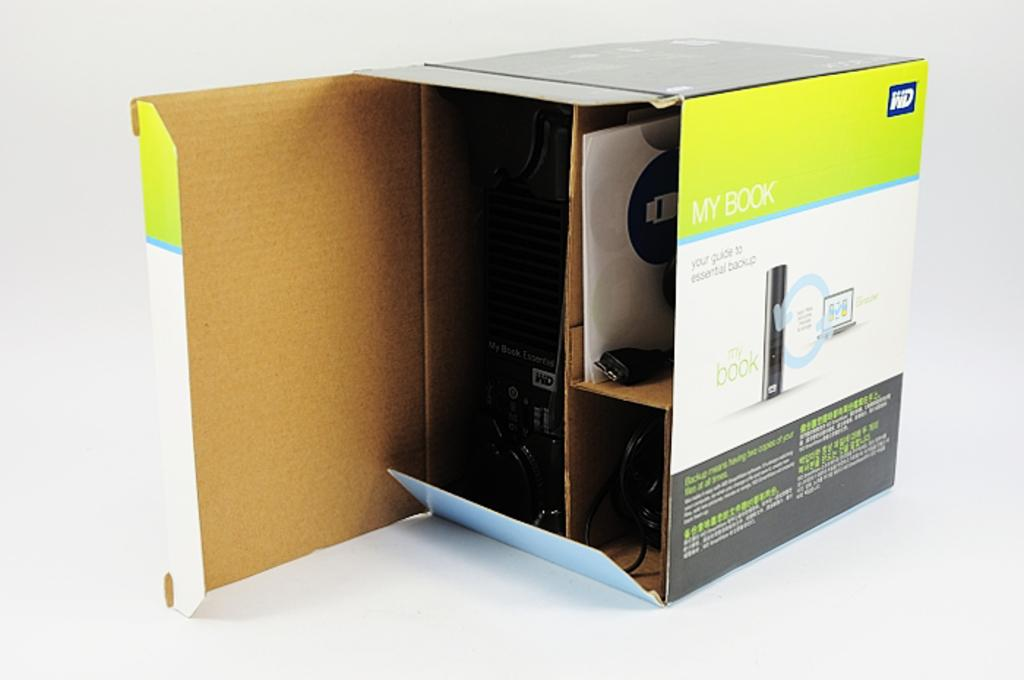What object can be seen in the image? There is a box in the image. What is inside the box? There is a device inside the box. How many cards are hanging on the wall inside the box? There are no cards or walls present in the image; it only features a box with a device inside. 